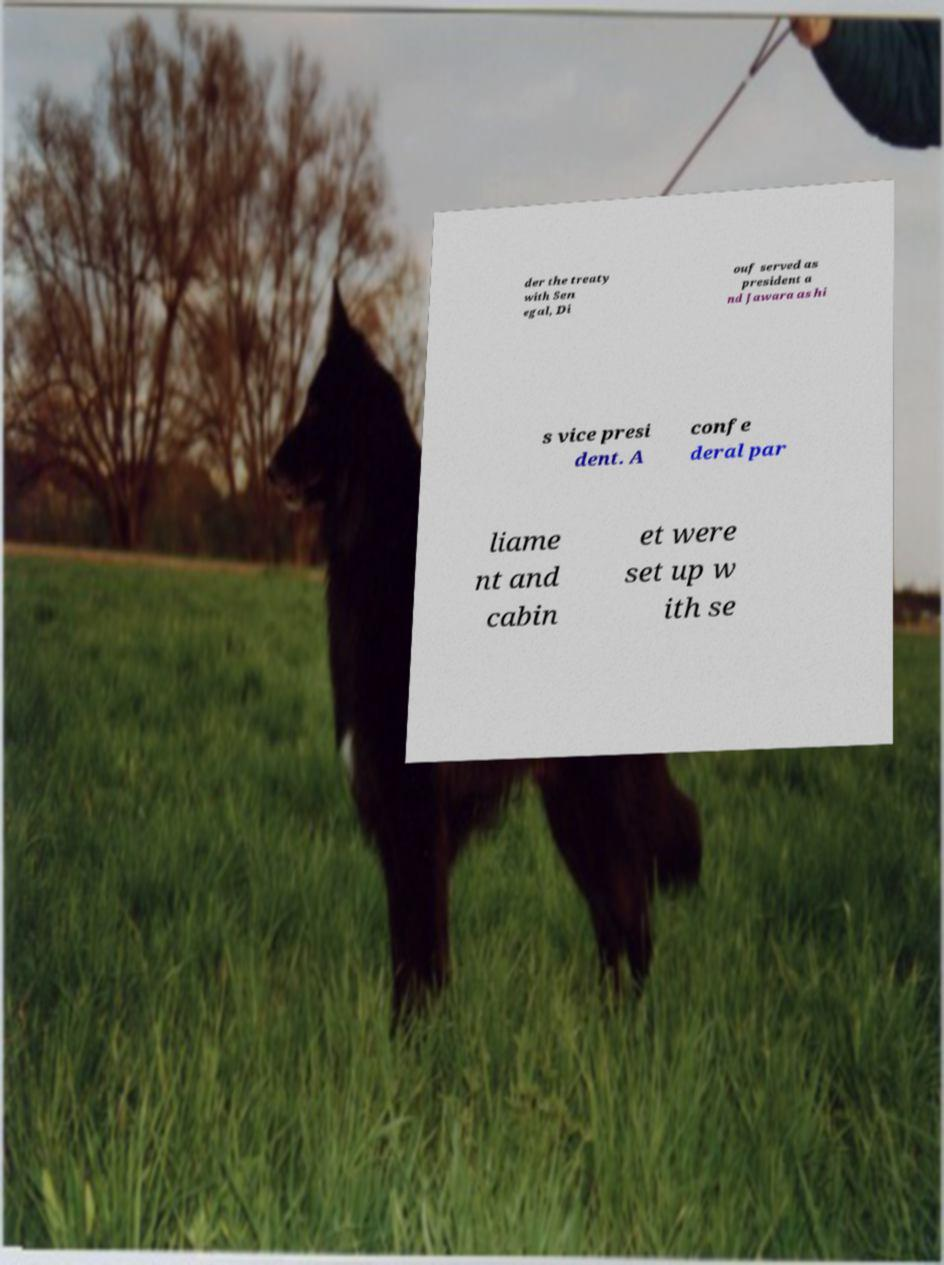What messages or text are displayed in this image? I need them in a readable, typed format. der the treaty with Sen egal, Di ouf served as president a nd Jawara as hi s vice presi dent. A confe deral par liame nt and cabin et were set up w ith se 